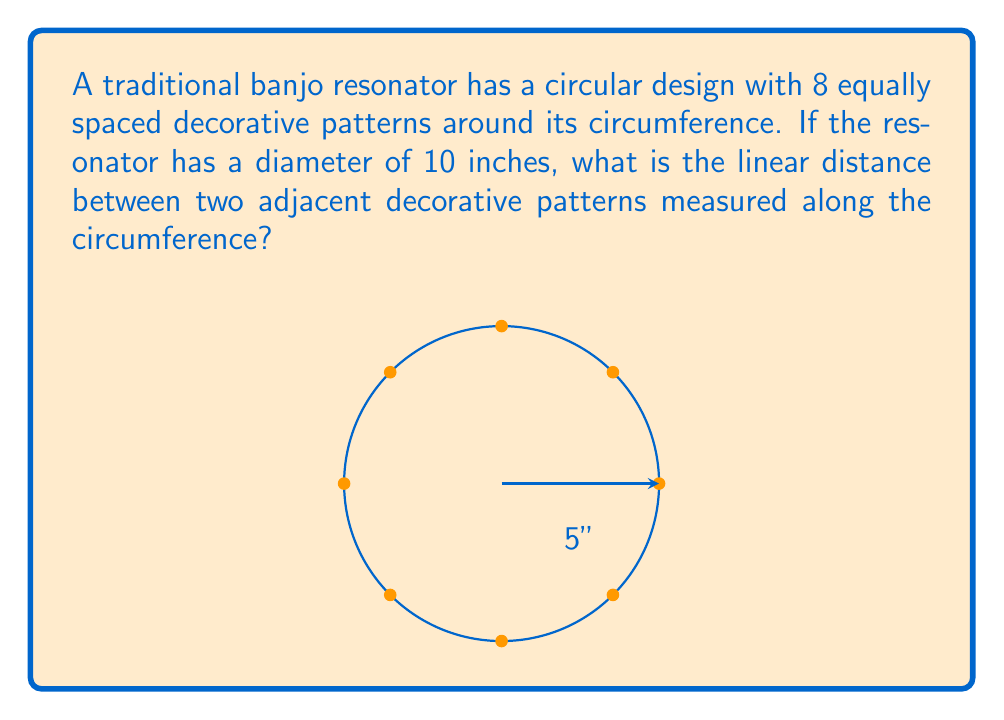What is the answer to this math problem? To solve this problem, we'll follow these steps:

1) First, recall that the circumference of a circle is given by the formula:
   $$C = \pi d$$
   where $C$ is the circumference and $d$ is the diameter.

2) Given the diameter of 10 inches, we can calculate the circumference:
   $$C = \pi \cdot 10 = 10\pi \text{ inches}$$

3) The decorative patterns are equally spaced around the circumference. Since there are 8 patterns, they divide the circumference into 8 equal parts.

4) To find the distance between adjacent patterns, we need to divide the total circumference by 8:
   $$\text{Distance} = \frac{10\pi}{8} = \frac{5\pi}{4} \text{ inches}$$

5) This can be simplified to:
   $$\frac{5\pi}{4} \approx 3.927 \text{ inches}$$

Therefore, the linear distance between two adjacent decorative patterns along the circumference is $\frac{5\pi}{4}$ inches or approximately 3.927 inches.
Answer: $\frac{5\pi}{4}$ inches 